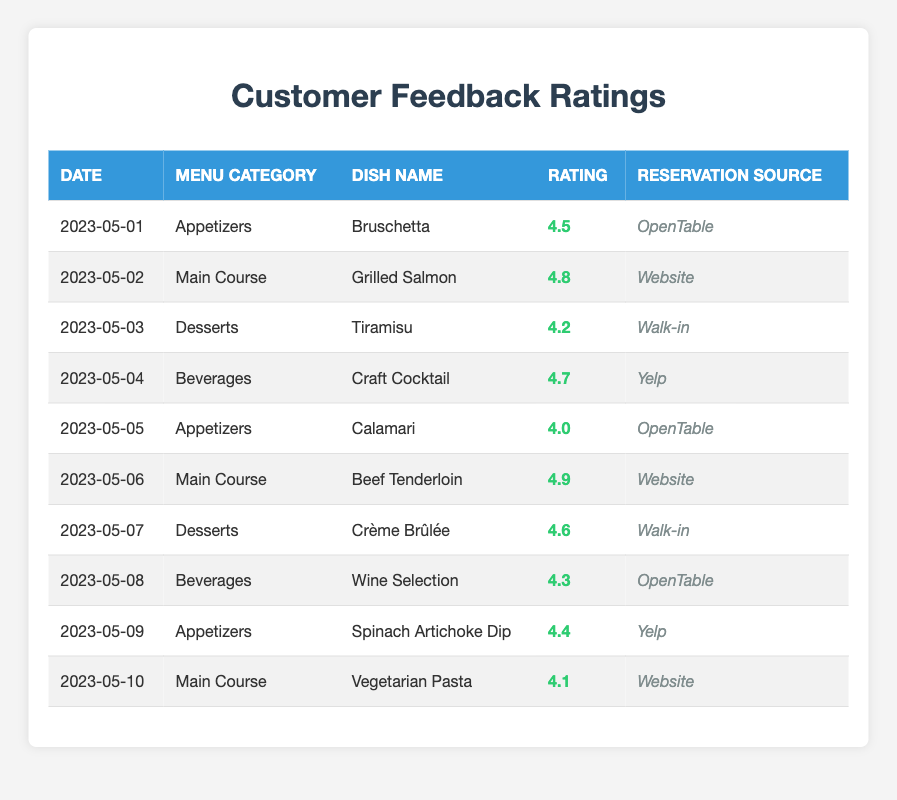What is the highest rating given to a dish in the Appetizers category? The Appetizers category has the following ratings: 4.5 (Bruschetta) and 4.0 (Calamari), and 4.4 (Spinach Artichoke Dip). The highest among these is 4.5 for Bruschetta.
Answer: 4.5 What was the reservation source for the dish with the lowest rating? The dish with the lowest rating is Vegetarian Pasta with a rating of 4.1, which was reserved via the Website.
Answer: Website What is the average rating for the Main Course category? The Main Course category includes the following ratings: 4.8 (Grilled Salmon), 4.9 (Beef Tenderloin), and 4.1 (Vegetarian Pasta). To find the average, sum these ratings (4.8 + 4.9 + 4.1 = 13.8) and divide by the number of dishes (3) to get 13.8 / 3 = 4.6.
Answer: 4.6 Was the dish Tiramisu rated higher than the Craft Cocktail? Tiramisu has a rating of 4.2, while Craft Cocktail has a rating of 4.7. Since 4.2 is less than 4.7, Tiramisu is not rated higher than Craft Cocktail.
Answer: No What was the total number of ratings collected for the Desserts category? The Desserts category includes Tiramisu with a rating of 4.2 and Crème Brûlée with a rating of 4.6, which means there are 2 ratings in total for this category.
Answer: 2 Which dish had the highest rating among all categories? The highest rating is 4.9 for the dish Beef Tenderloin in the Main Course category.
Answer: Beef Tenderloin Which menu category has the most dishes rated in this data? There are 3 dishes in the Appetizers category (Bruschetta, Calamari, Spinach Artichoke Dip), 3 in the Main Course category (Grilled Salmon, Beef Tenderloin, Vegetarian Pasta), 2 in Desserts (Tiramisu, Crème Brûlée), and 2 in Beverages (Craft Cocktail, Wine Selection). Appetizers and Main Course are tied at 3 dishes each, making them the categories with the most.
Answer: Appetizers and Main Course What is the difference between the highest and lowest ratings in the Beverages category? The Beverages category includes Craft Cocktail with a rating of 4.7 and Wine Selection with a rating of 4.3. To find the difference, subtract the lowest rating from the highest: 4.7 - 4.3 = 0.4.
Answer: 0.4 